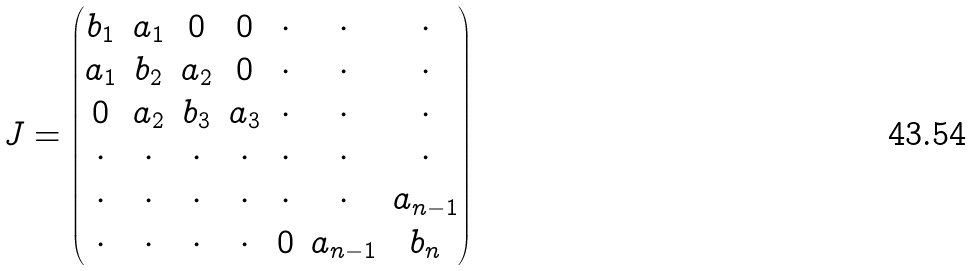<formula> <loc_0><loc_0><loc_500><loc_500>J = \begin{pmatrix} b _ { 1 } & a _ { 1 } & 0 & 0 & \cdot & \cdot & \cdot \\ a _ { 1 } & b _ { 2 } & a _ { 2 } & 0 & \cdot & \cdot & \cdot \\ 0 & a _ { 2 } & b _ { 3 } & a _ { 3 } & \cdot & \cdot & \cdot \\ \cdot & \cdot & \cdot & \cdot & \cdot & \cdot & \cdot \\ \cdot & \cdot & \cdot & \cdot & \cdot & \cdot & a _ { n - 1 } \\ \cdot & \cdot & \cdot & \cdot & 0 & a _ { n - 1 } & b _ { n } \end{pmatrix}</formula> 